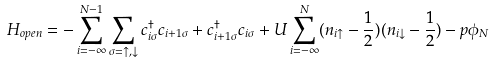Convert formula to latex. <formula><loc_0><loc_0><loc_500><loc_500>H _ { o p e n } = - \sum _ { i = - \infty } ^ { N - 1 } \sum _ { \sigma = \uparrow , \downarrow } c _ { i \sigma } ^ { \dagger } c _ { i + 1 \sigma } + c _ { i + 1 \sigma } ^ { \dagger } c _ { i \sigma } + U \sum _ { i = - \infty } ^ { N } ( n _ { i \uparrow } - \frac { 1 } { 2 } ) ( n _ { i \downarrow } - \frac { 1 } { 2 } ) - p \phi _ { N }</formula> 